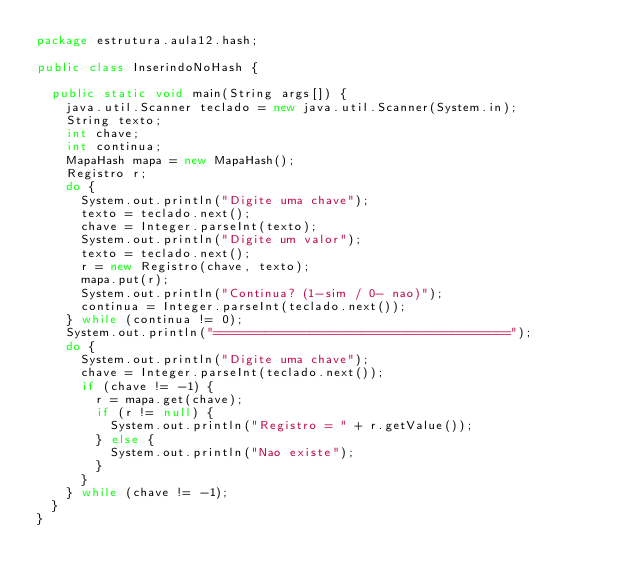Convert code to text. <code><loc_0><loc_0><loc_500><loc_500><_Java_>package estrutura.aula12.hash;

public class InserindoNoHash {

	public static void main(String args[]) {
		java.util.Scanner teclado = new java.util.Scanner(System.in);
		String texto;
		int chave;
		int continua;
		MapaHash mapa = new MapaHash();
		Registro r;
		do {
			System.out.println("Digite uma chave");
			texto = teclado.next();
			chave = Integer.parseInt(texto);
			System.out.println("Digite um valor");
			texto = teclado.next();
			r = new Registro(chave, texto);
			mapa.put(r);
			System.out.println("Continua? (1-sim / 0- nao)");
			continua = Integer.parseInt(teclado.next());
		} while (continua != 0);
		System.out.println("========================================");
		do {
			System.out.println("Digite uma chave");
			chave = Integer.parseInt(teclado.next());
			if (chave != -1) {
				r = mapa.get(chave);
				if (r != null) {
					System.out.println("Registro = " + r.getValue());
				} else {
					System.out.println("Nao existe");
				}
			}
		} while (chave != -1);
	}
}
</code> 